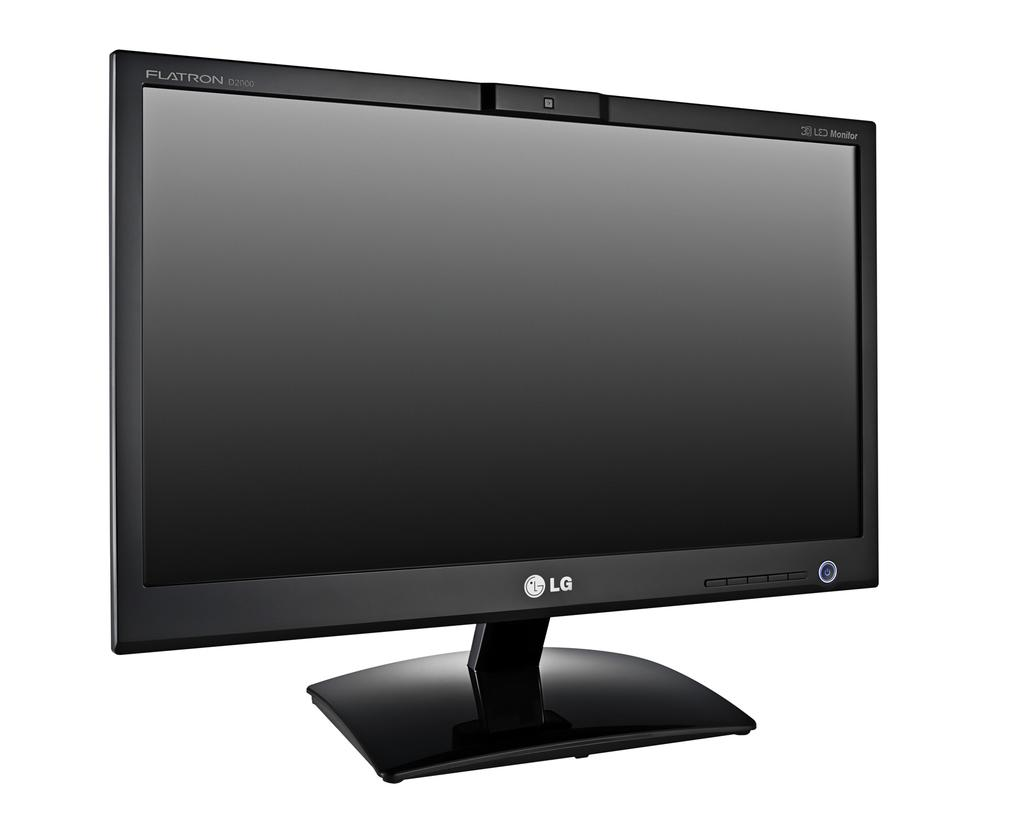What type of TV is in the image? There is a black color TV in the image. Does the TV have any distinguishing features? Yes, the TV has a logo. What else can be seen on the TV? There is something written on the TV. What is the color of the background in the image? The background of the image is white in color. Can you tell me how many giraffes are standing next to the TV in the image? There are no giraffes present in the image; it only features a black color TV with a logo and writing on it. What command is given to the TV in the image? There is no command given to the TV in the image; it is a still image of a TV with a logo and writing on it. 